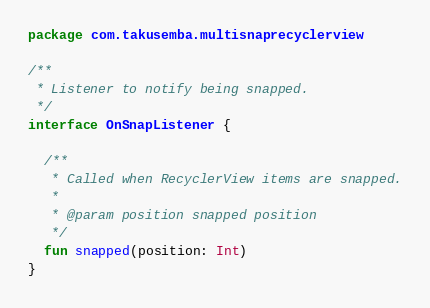<code> <loc_0><loc_0><loc_500><loc_500><_Kotlin_>package com.takusemba.multisnaprecyclerview

/**
 * Listener to notify being snapped.
 */
interface OnSnapListener {

  /**
   * Called when RecyclerView items are snapped.
   *
   * @param position snapped position
   */
  fun snapped(position: Int)
}
</code> 